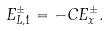Convert formula to latex. <formula><loc_0><loc_0><loc_500><loc_500>E ^ { \pm } _ { L , 1 } = - C E ^ { \pm } _ { x } .</formula> 